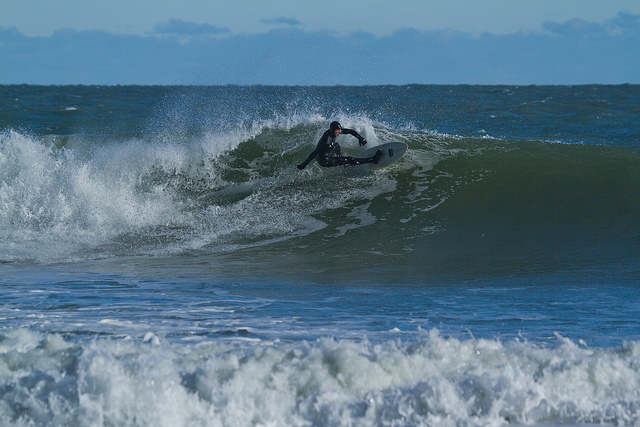<image>What type of boat is pulling the wakeboarder? There is no boat in the image. However, it could be a yacht, speed boat, small boat or power boat. What type of boat is pulling the wakeboarder? I don't know what type of boat is pulling the wakeboarder. It could be a yacht, a speed boat, a small boat, or a power boat. 